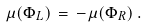Convert formula to latex. <formula><loc_0><loc_0><loc_500><loc_500>\mu ( \Phi _ { L } ) \, = \, - \mu ( \Phi _ { R } ) \, .</formula> 